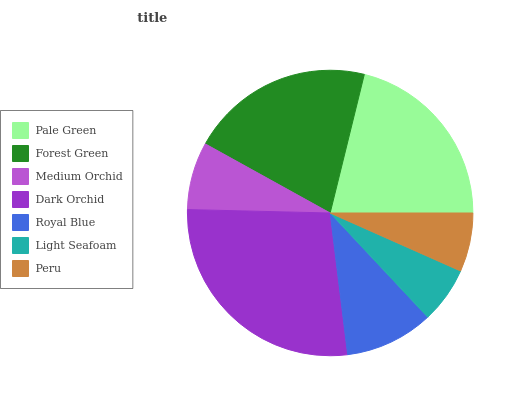Is Light Seafoam the minimum?
Answer yes or no. Yes. Is Dark Orchid the maximum?
Answer yes or no. Yes. Is Forest Green the minimum?
Answer yes or no. No. Is Forest Green the maximum?
Answer yes or no. No. Is Pale Green greater than Forest Green?
Answer yes or no. Yes. Is Forest Green less than Pale Green?
Answer yes or no. Yes. Is Forest Green greater than Pale Green?
Answer yes or no. No. Is Pale Green less than Forest Green?
Answer yes or no. No. Is Royal Blue the high median?
Answer yes or no. Yes. Is Royal Blue the low median?
Answer yes or no. Yes. Is Light Seafoam the high median?
Answer yes or no. No. Is Forest Green the low median?
Answer yes or no. No. 